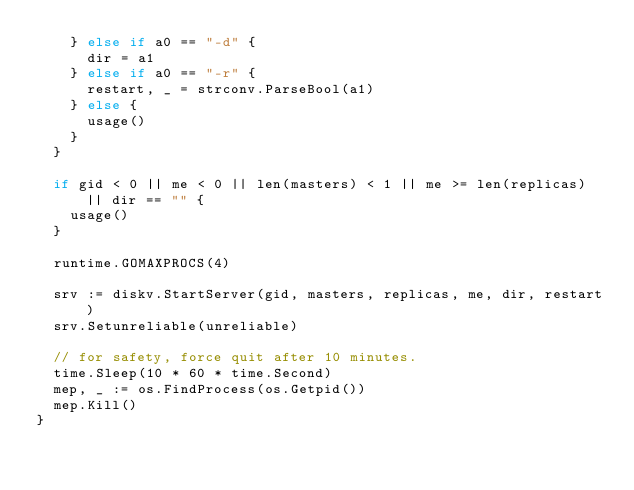Convert code to text. <code><loc_0><loc_0><loc_500><loc_500><_Go_>		} else if a0 == "-d" {
			dir = a1
		} else if a0 == "-r" {
			restart, _ = strconv.ParseBool(a1)
		} else {
			usage()
		}
	}

	if gid < 0 || me < 0 || len(masters) < 1 || me >= len(replicas) || dir == "" {
		usage()
	}

	runtime.GOMAXPROCS(4)

	srv := diskv.StartServer(gid, masters, replicas, me, dir, restart)
	srv.Setunreliable(unreliable)

	// for safety, force quit after 10 minutes.
	time.Sleep(10 * 60 * time.Second)
	mep, _ := os.FindProcess(os.Getpid())
	mep.Kill()
}
</code> 